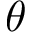Convert formula to latex. <formula><loc_0><loc_0><loc_500><loc_500>\theta</formula> 